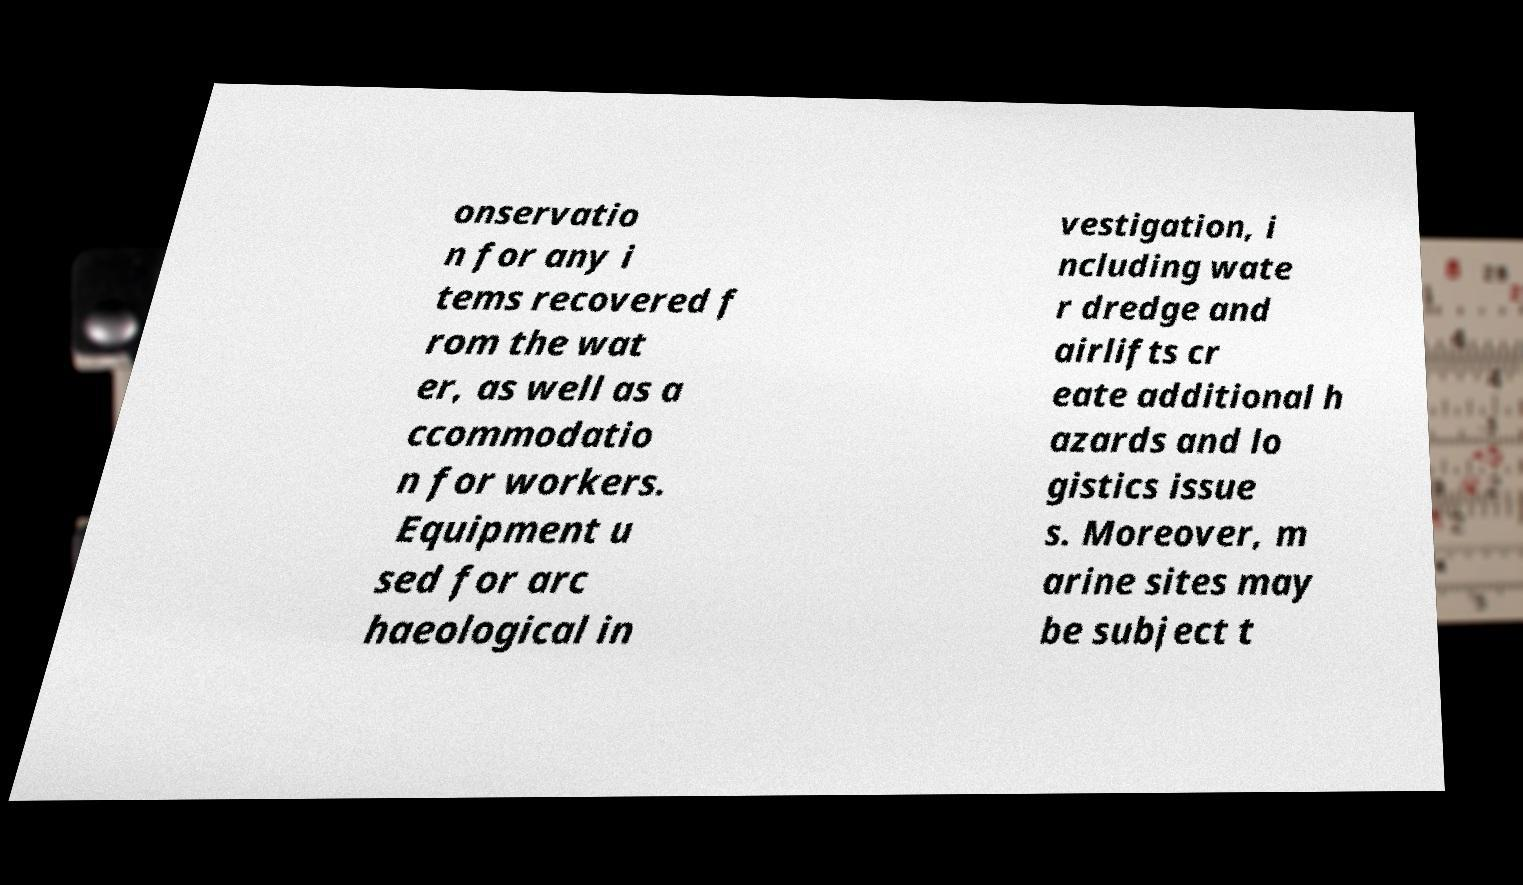Please read and relay the text visible in this image. What does it say? onservatio n for any i tems recovered f rom the wat er, as well as a ccommodatio n for workers. Equipment u sed for arc haeological in vestigation, i ncluding wate r dredge and airlifts cr eate additional h azards and lo gistics issue s. Moreover, m arine sites may be subject t 